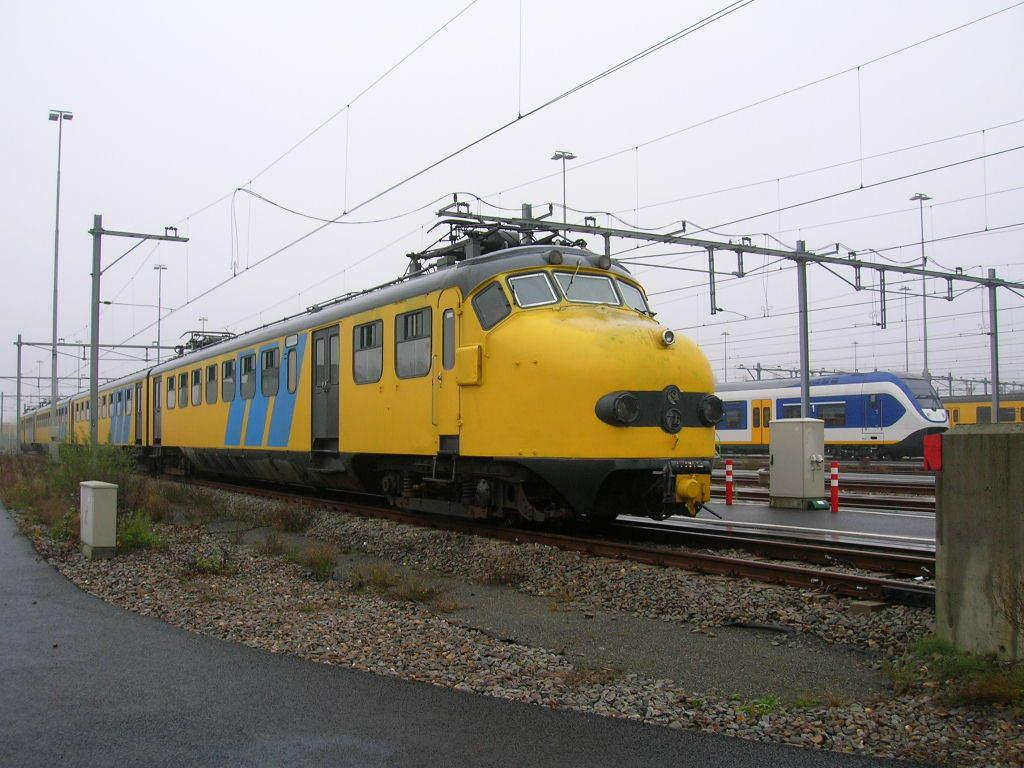What type of vehicles are in the image? There are trains in the image. Where are the trains located? The trains are on railway tracks. What can be seen in the background of the image? There are poles with wires attached to them, the sky, plants, and other unspecified objects in the background. What type of pies are being served on the tray in the image? There is no tray or pies present in the image; it features trains on railway tracks with a background that includes poles with wires, the sky, plants, and other unspecified objects. 